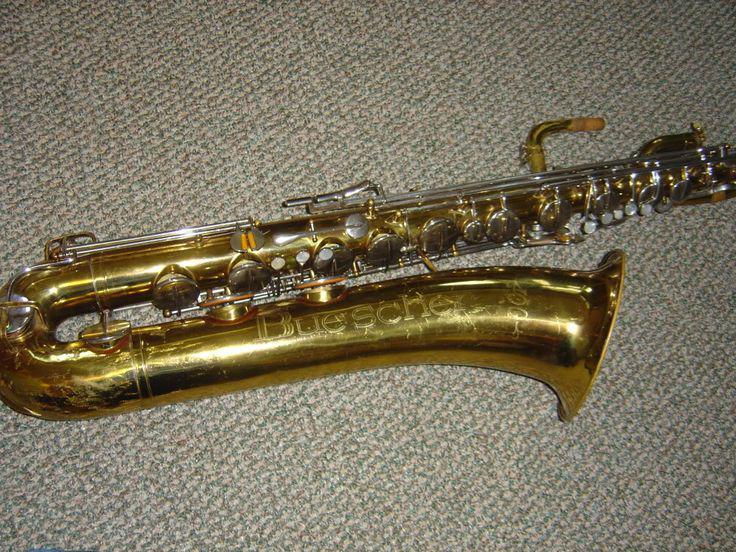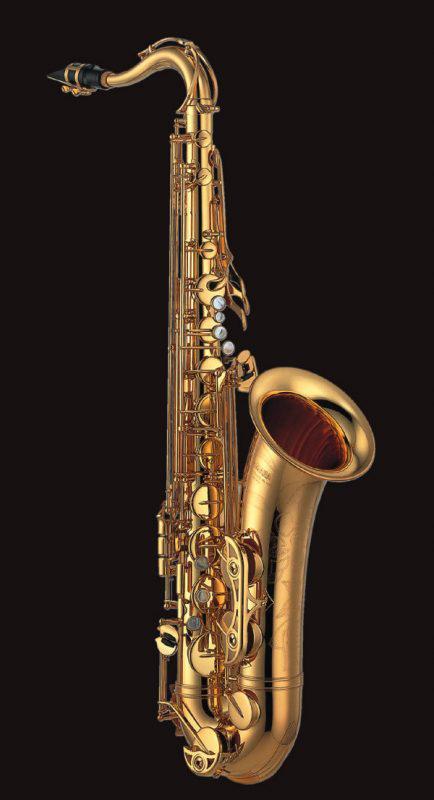The first image is the image on the left, the second image is the image on the right. Considering the images on both sides, is "A man in a short-sleeved black shirt is holding a saxophone." valid? Answer yes or no. No. The first image is the image on the left, the second image is the image on the right. Examine the images to the left and right. Is the description "A man is holding the saxophone in the image on the right." accurate? Answer yes or no. No. 